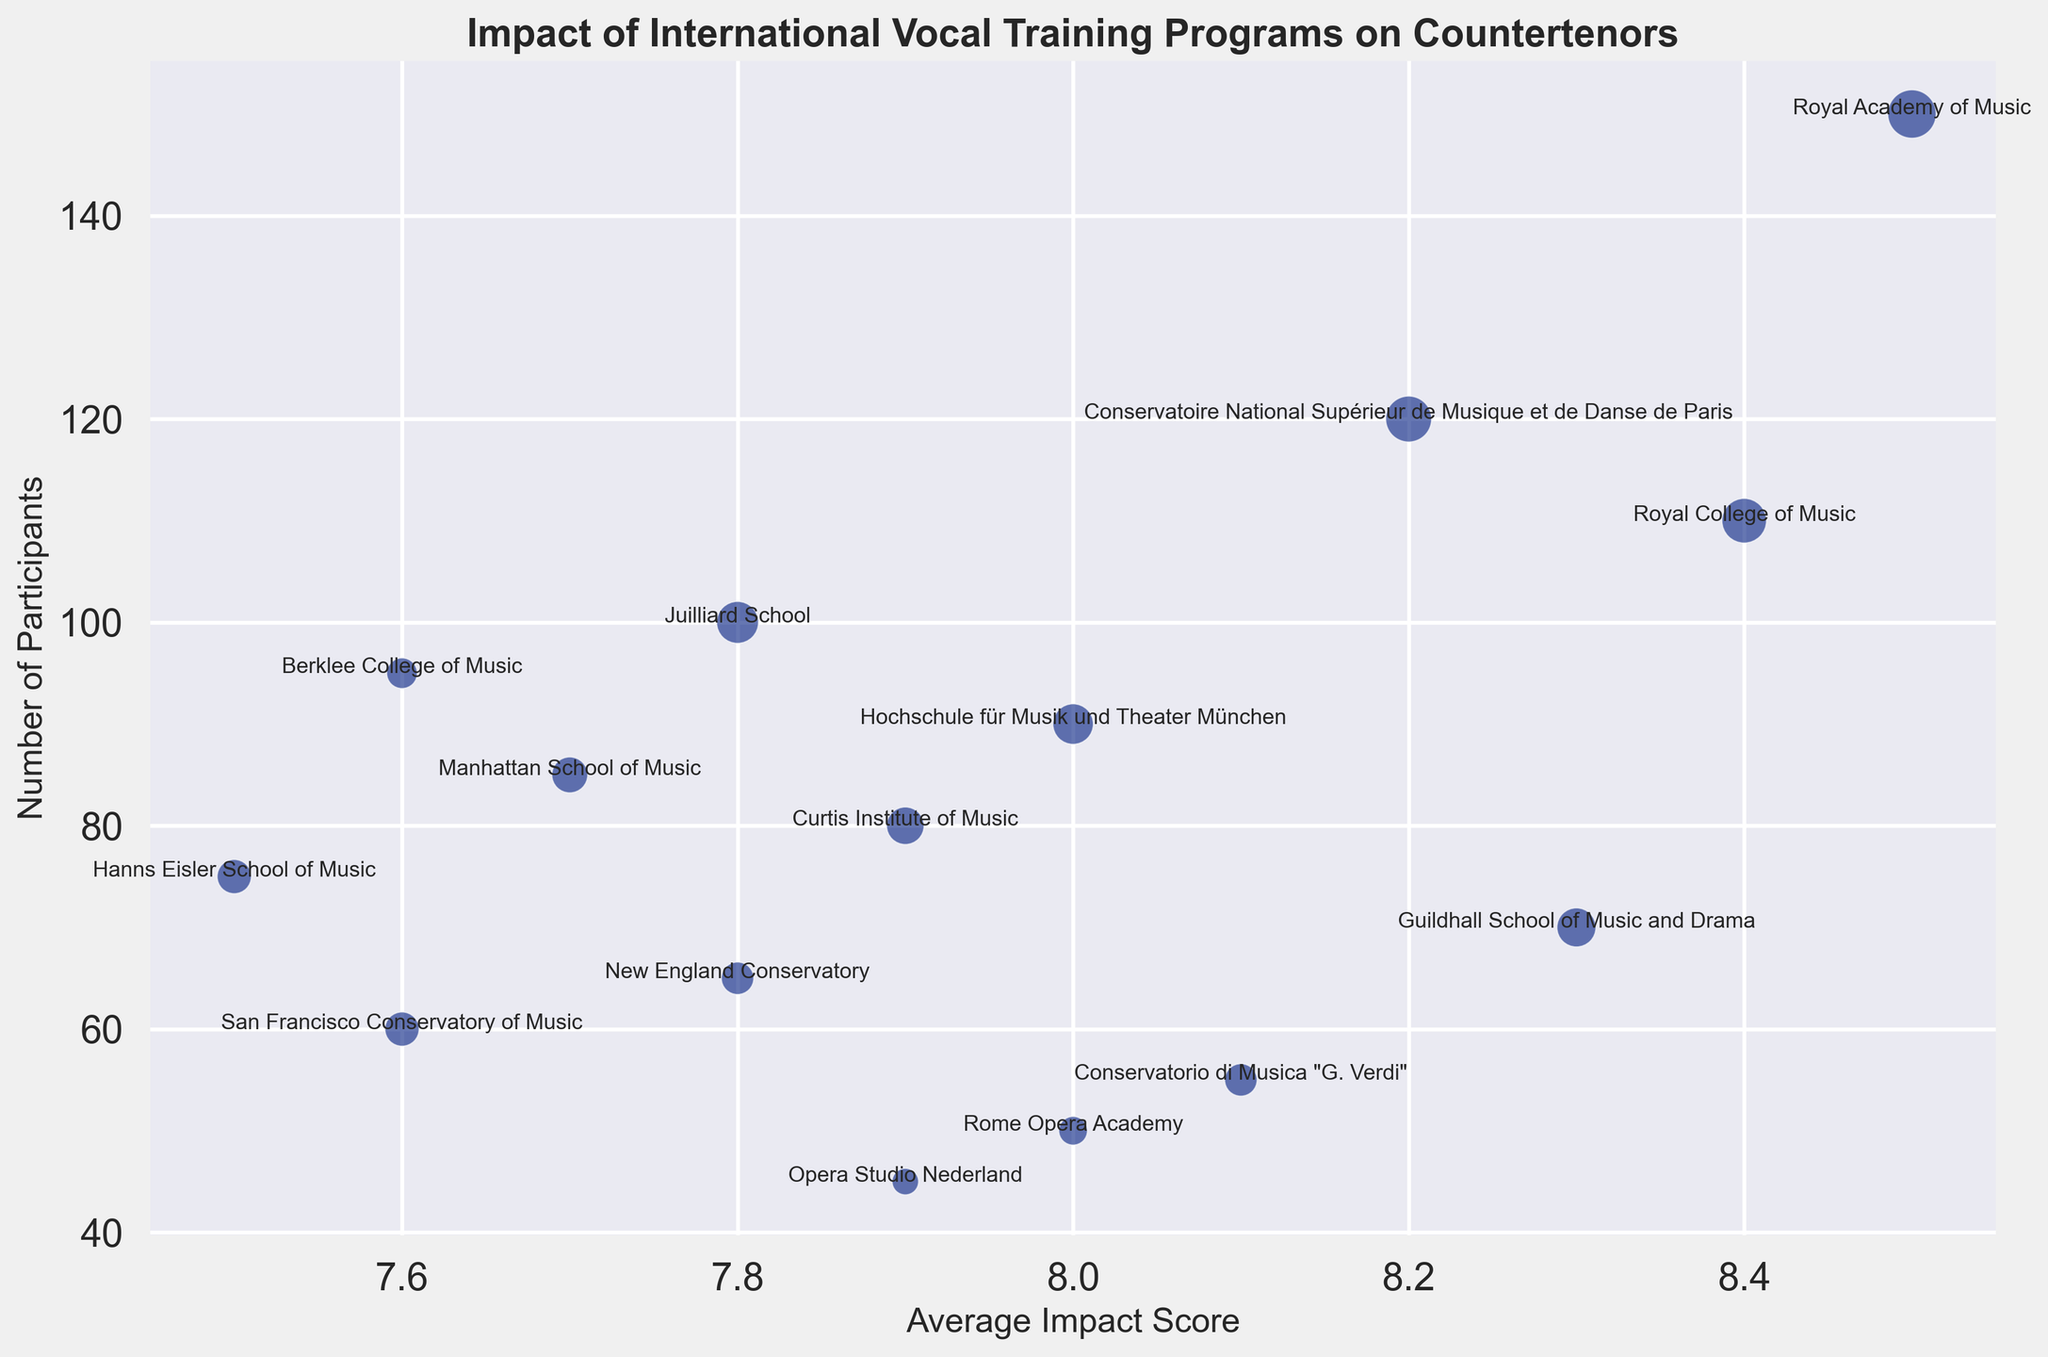Which program has the highest average impact score? Look for the bubble closest to the right side of the x-axis (the impact score axis). The Royal Academy of Music has the highest average impact score of 8.5.
Answer: Royal Academy of Music Which program has the largest number of participants? Identify the bubble highest on the y-axis (the number of participants axis). The Royal Academy of Music has the highest number of participants at 150.
Answer: Royal Academy of Music How many countertenors does the Royal College of Music have? Locate the bubble labeled Royal College of Music and check the corresponding value for the number of countertenors. The Royal College of Music has 17 countertenors.
Answer: 17 Which city has the most programs listed? Look at the location of the programs in the figure and count the number for each city. London has three programs listed: Royal Academy of Music, Guildhall School of Music and Drama, and Royal College of Music.
Answer: London What is the difference in the number of participants between the Juilliard School and the Curtis Institute of Music? Subtract the number of participants for Curtis Institute of Music (80) from that of Juilliard School (100). The difference is 20.
Answer: 20 Which European program has the lowest average impact score? Look for the lowest impact score among European programs. The Hanns Eisler School of Music in Berlin has the lowest impact score of 7.5.
Answer: Hanns Eisler School of Music Comparing Royal Academy of Music and Juilliard School, which has a higher number of countertenors? Compare the number of countertenors for both programs. The Royal Academy of Music has 20 countertenors, and Juilliard School has 15.
Answer: Royal Academy of Music Which program is represented by the smallest bubble? Find the smallest bubble which corresponds to the program with the least number of countertenors: Opera Studio Nederland with 6 countertenors.
Answer: Opera Studio Nederland Is there any program in the visual that has the same number of participants but different impact scores? Compare the number of participants of each program to check if any two have the same number but different impact scores. There is no such pair in the given data based on visual inspection.
Answer: No Which European program has the highest number of participants? Among European programs, find the bubble that is highest on the y-axis. The Royal Academy of Music in London has the highest number of participants at 150.
Answer: Royal Academy of Music 